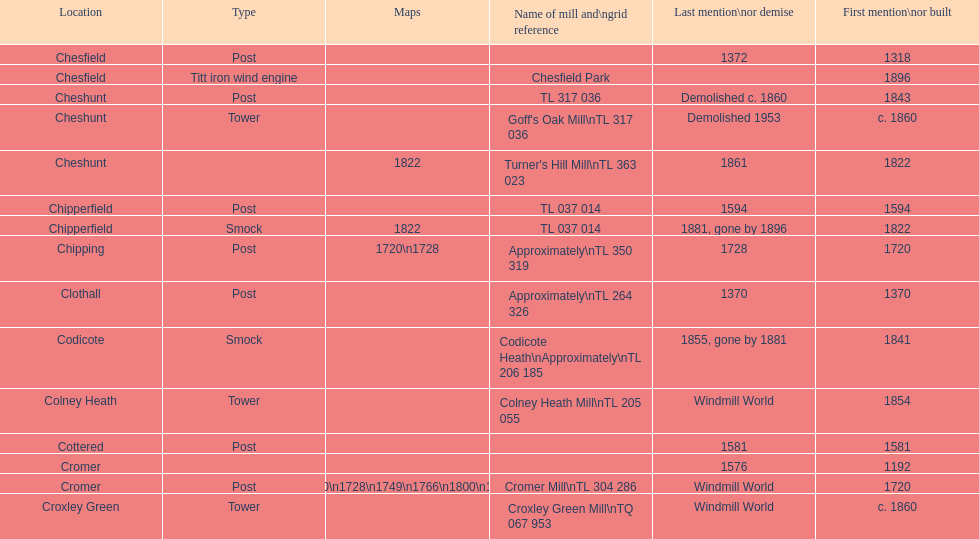How many mills were mentioned or built before 1700? 5. 